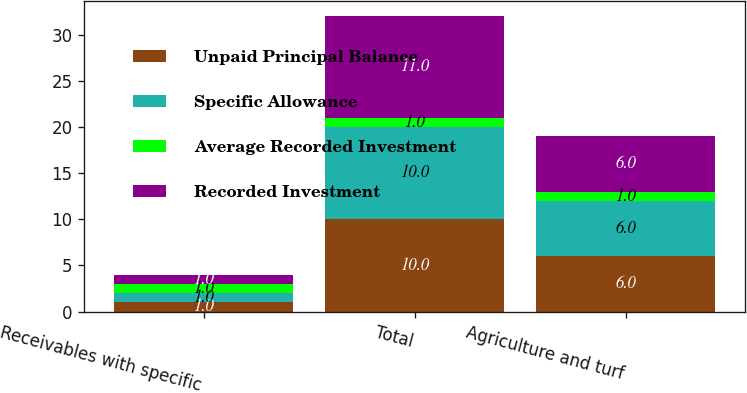Convert chart. <chart><loc_0><loc_0><loc_500><loc_500><stacked_bar_chart><ecel><fcel>Receivables with specific<fcel>Total<fcel>Agriculture and turf<nl><fcel>Unpaid Principal Balance<fcel>1<fcel>10<fcel>6<nl><fcel>Specific Allowance<fcel>1<fcel>10<fcel>6<nl><fcel>Average Recorded Investment<fcel>1<fcel>1<fcel>1<nl><fcel>Recorded Investment<fcel>1<fcel>11<fcel>6<nl></chart> 